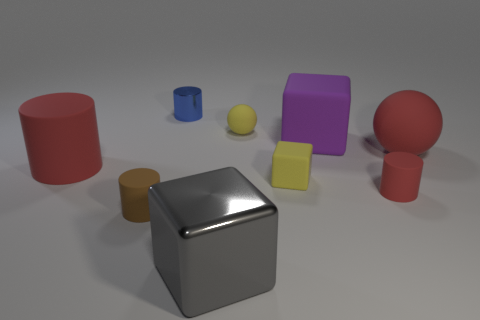Subtract all small brown cylinders. How many cylinders are left? 3 Subtract all blue cylinders. How many cylinders are left? 3 Add 1 matte balls. How many objects exist? 10 Subtract 3 cylinders. How many cylinders are left? 1 Subtract all red cylinders. Subtract all yellow balls. How many cylinders are left? 2 Subtract all gray blocks. How many red cylinders are left? 2 Subtract all large purple cylinders. Subtract all large gray things. How many objects are left? 8 Add 2 red matte objects. How many red matte objects are left? 5 Add 4 large balls. How many large balls exist? 5 Subtract 1 yellow cubes. How many objects are left? 8 